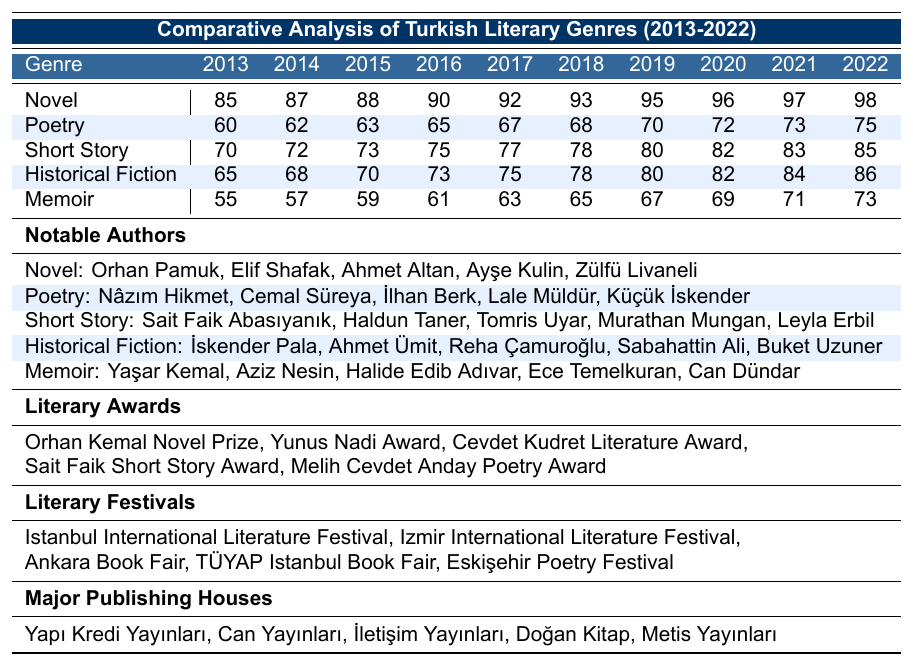What was the popularity of the Novel genre in 2015? The table shows that the popularity of the Novel genre in 2015 is listed as 88.
Answer: 88 Which genre had the lowest popularity in 2013? According to the table, in 2013, the Memoir genre had the lowest popularity at 55.
Answer: Memoir What has been the trend in popularity for Poetry from 2013 to 2022? The table indicates that Poetry's popularity increased from 60 in 2013 to 75 in 2022, showing a gradual upward trend over the years.
Answer: Gradual upward trend How much did the popularity of Short Story increase from 2013 to 2022? In 2013, Short Story's popularity was 70, and by 2022 it had increased to 85. The increase is calculated as 85 - 70 = 15.
Answer: 15 Which genre had the highest popularity in 2022? The table reveals that in 2022, the Novel genre had the highest popularity with a score of 98, compared to all other genres listed.
Answer: Novel What was the average popularity of the Historical Fiction genre over the decade? To find the average popularity, add up the values from 2013 to 2022 (65 + 68 + 70 + 73 + 75 + 78 + 80 + 82 + 84 + 86 = 790) and divide by the number of years (10). The average is 790 / 10 = 79.
Answer: 79 How many more points popular is the Novel genre compared to the Memoir genre in 2022? In 2022, the Novel genre had a popularity of 98 and the Memoir genre had a popularity of 73. The difference is calculated as 98 - 73 = 25.
Answer: 25 Was there any year when the Short Story genre's popularity was higher than Poetry? By comparing the values, it can be observed that from 2013 to 2022, Short Story was consistently more popular than Poetry, confirming this is true.
Answer: Yes What notable authors are associated with the Historical Fiction genre? The table lists the notable authors for Historical Fiction as İskender Pala, Ahmet Ümit, Reha Çamuroğlu, Sabahattin Ali, and Buket Uzuner.
Answer: İskender Pala, Ahmet Ümit, Reha Çamuroğlu, Sabahattin Ali, Buket Uzuner In which year did the Memoir genre see its highest popularity? The most recent data indicates that in 2022, the Memoir genre reached its highest popularity of 73.
Answer: 2022 What is the total popularity score for all genres in 2020? To find the total popularity in 2020, sum all values for that year: Novel (96) + Poetry (72) + Short Story (82) + Historical Fiction (82) + Memoir (69) = 401.
Answer: 401 